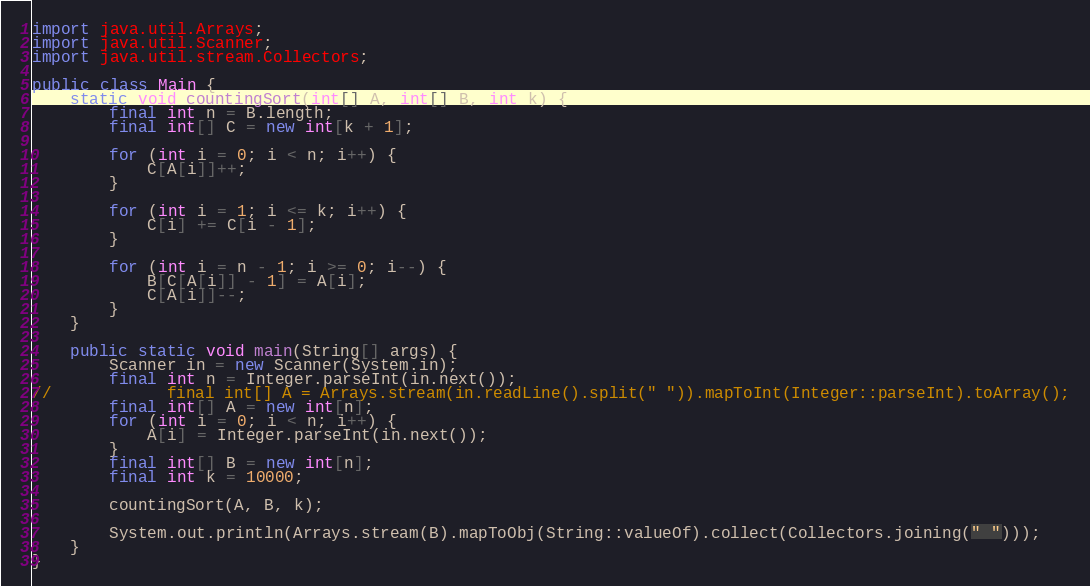<code> <loc_0><loc_0><loc_500><loc_500><_Java_>import java.util.Arrays;
import java.util.Scanner;
import java.util.stream.Collectors;

public class Main {
    static void countingSort(int[] A, int[] B, int k) {
        final int n = B.length;
        final int[] C = new int[k + 1];

        for (int i = 0; i < n; i++) {
            C[A[i]]++;
        }

        for (int i = 1; i <= k; i++) {
            C[i] += C[i - 1];
        }

        for (int i = n - 1; i >= 0; i--) {
            B[C[A[i]] - 1] = A[i];
            C[A[i]]--;
        }
    }

    public static void main(String[] args) {
        Scanner in = new Scanner(System.in);
        final int n = Integer.parseInt(in.next());
//            final int[] A = Arrays.stream(in.readLine().split(" ")).mapToInt(Integer::parseInt).toArray();
        final int[] A = new int[n];
        for (int i = 0; i < n; i++) {
            A[i] = Integer.parseInt(in.next());
        }
        final int[] B = new int[n];
        final int k = 10000;

        countingSort(A, B, k);

        System.out.println(Arrays.stream(B).mapToObj(String::valueOf).collect(Collectors.joining(" ")));
    }
}

</code> 